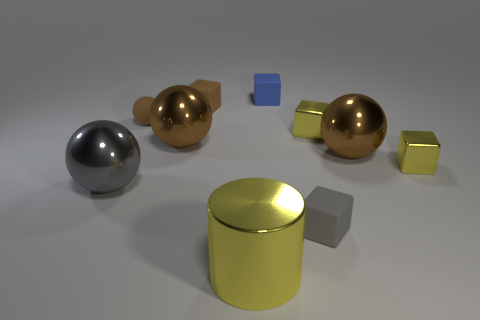How many tiny blue matte things are there?
Provide a short and direct response. 1. Is the large cylinder made of the same material as the small brown ball?
Offer a very short reply. No. What is the shape of the yellow object in front of the gray thing that is behind the small rubber cube in front of the big gray object?
Ensure brevity in your answer.  Cylinder. Does the sphere left of the tiny brown ball have the same material as the tiny cube that is left of the tiny blue cube?
Provide a short and direct response. No. What is the cylinder made of?
Your answer should be very brief. Metal. What number of other objects have the same shape as the blue matte object?
Your response must be concise. 4. There is a small cube that is the same color as the matte ball; what is it made of?
Provide a succinct answer. Rubber. Are there any other things that are the same shape as the gray matte object?
Keep it short and to the point. Yes. What color is the large ball that is right of the tiny object that is in front of the big gray metallic object that is behind the big yellow metallic object?
Your answer should be compact. Brown. What number of big things are gray shiny spheres or brown metallic balls?
Offer a very short reply. 3. 